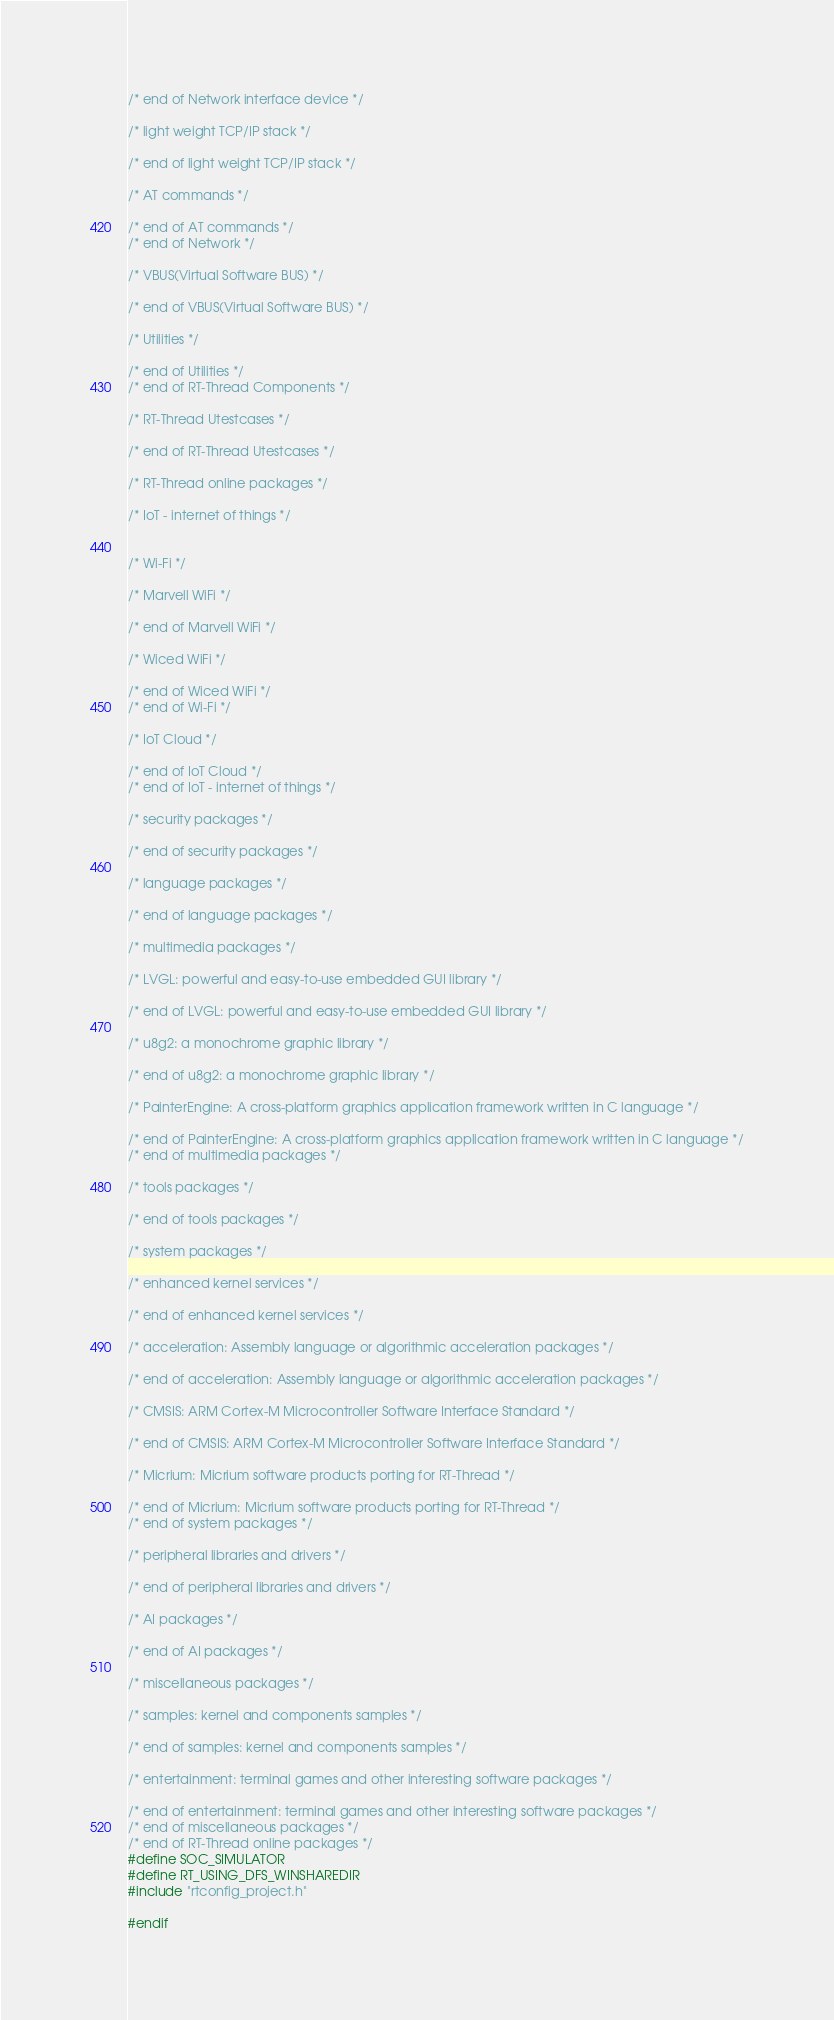<code> <loc_0><loc_0><loc_500><loc_500><_C_>/* end of Network interface device */

/* light weight TCP/IP stack */

/* end of light weight TCP/IP stack */

/* AT commands */

/* end of AT commands */
/* end of Network */

/* VBUS(Virtual Software BUS) */

/* end of VBUS(Virtual Software BUS) */

/* Utilities */

/* end of Utilities */
/* end of RT-Thread Components */

/* RT-Thread Utestcases */

/* end of RT-Thread Utestcases */

/* RT-Thread online packages */

/* IoT - internet of things */


/* Wi-Fi */

/* Marvell WiFi */

/* end of Marvell WiFi */

/* Wiced WiFi */

/* end of Wiced WiFi */
/* end of Wi-Fi */

/* IoT Cloud */

/* end of IoT Cloud */
/* end of IoT - internet of things */

/* security packages */

/* end of security packages */

/* language packages */

/* end of language packages */

/* multimedia packages */

/* LVGL: powerful and easy-to-use embedded GUI library */

/* end of LVGL: powerful and easy-to-use embedded GUI library */

/* u8g2: a monochrome graphic library */

/* end of u8g2: a monochrome graphic library */

/* PainterEngine: A cross-platform graphics application framework written in C language */

/* end of PainterEngine: A cross-platform graphics application framework written in C language */
/* end of multimedia packages */

/* tools packages */

/* end of tools packages */

/* system packages */

/* enhanced kernel services */

/* end of enhanced kernel services */

/* acceleration: Assembly language or algorithmic acceleration packages */

/* end of acceleration: Assembly language or algorithmic acceleration packages */

/* CMSIS: ARM Cortex-M Microcontroller Software Interface Standard */

/* end of CMSIS: ARM Cortex-M Microcontroller Software Interface Standard */

/* Micrium: Micrium software products porting for RT-Thread */

/* end of Micrium: Micrium software products porting for RT-Thread */
/* end of system packages */

/* peripheral libraries and drivers */

/* end of peripheral libraries and drivers */

/* AI packages */

/* end of AI packages */

/* miscellaneous packages */

/* samples: kernel and components samples */

/* end of samples: kernel and components samples */

/* entertainment: terminal games and other interesting software packages */

/* end of entertainment: terminal games and other interesting software packages */
/* end of miscellaneous packages */
/* end of RT-Thread online packages */
#define SOC_SIMULATOR
#define RT_USING_DFS_WINSHAREDIR
#include "rtconfig_project.h"

#endif
</code> 